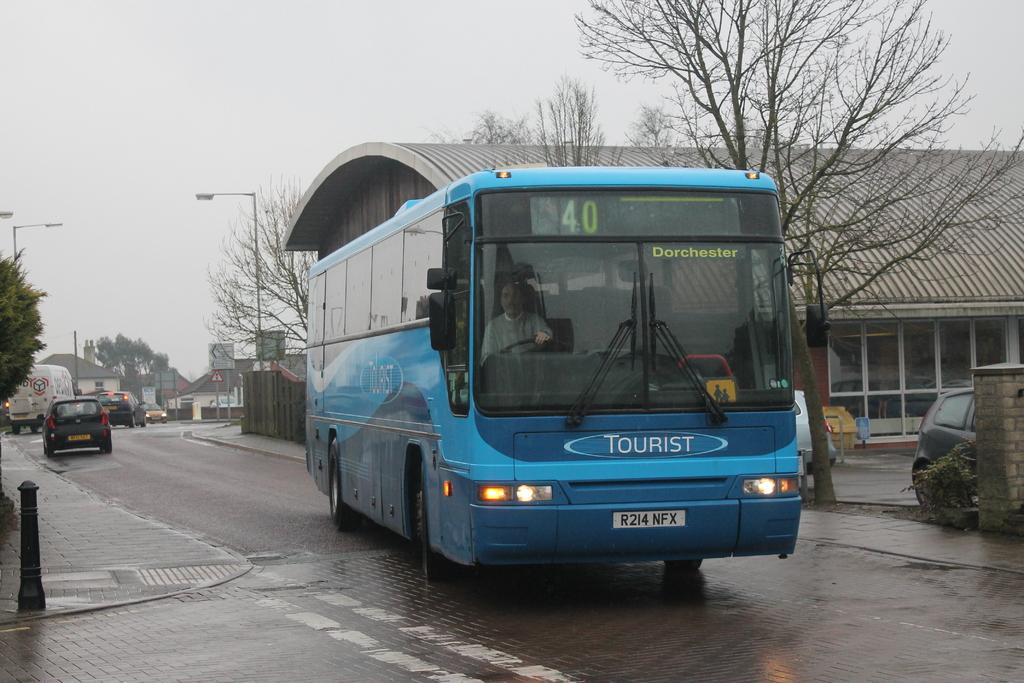<image>
Offer a succinct explanation of the picture presented. A blue tourist bus is numbered 40 and is on the street. 